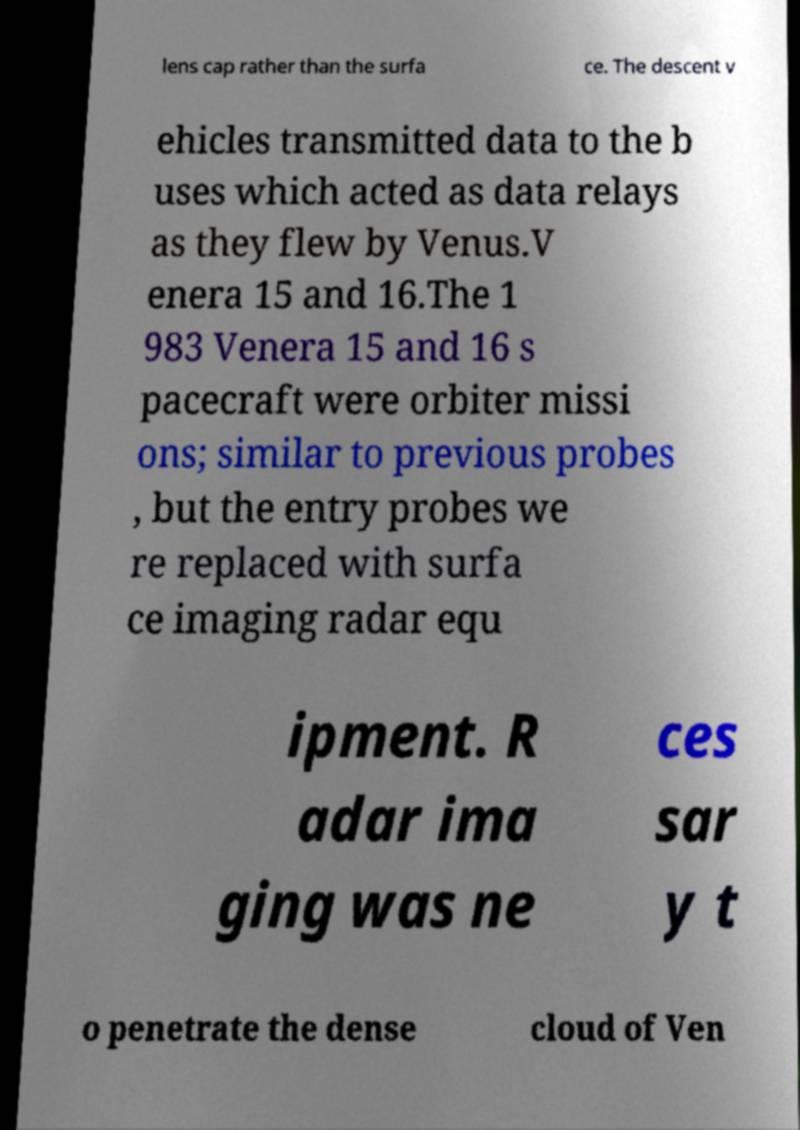Can you read and provide the text displayed in the image?This photo seems to have some interesting text. Can you extract and type it out for me? lens cap rather than the surfa ce. The descent v ehicles transmitted data to the b uses which acted as data relays as they flew by Venus.V enera 15 and 16.The 1 983 Venera 15 and 16 s pacecraft were orbiter missi ons; similar to previous probes , but the entry probes we re replaced with surfa ce imaging radar equ ipment. R adar ima ging was ne ces sar y t o penetrate the dense cloud of Ven 